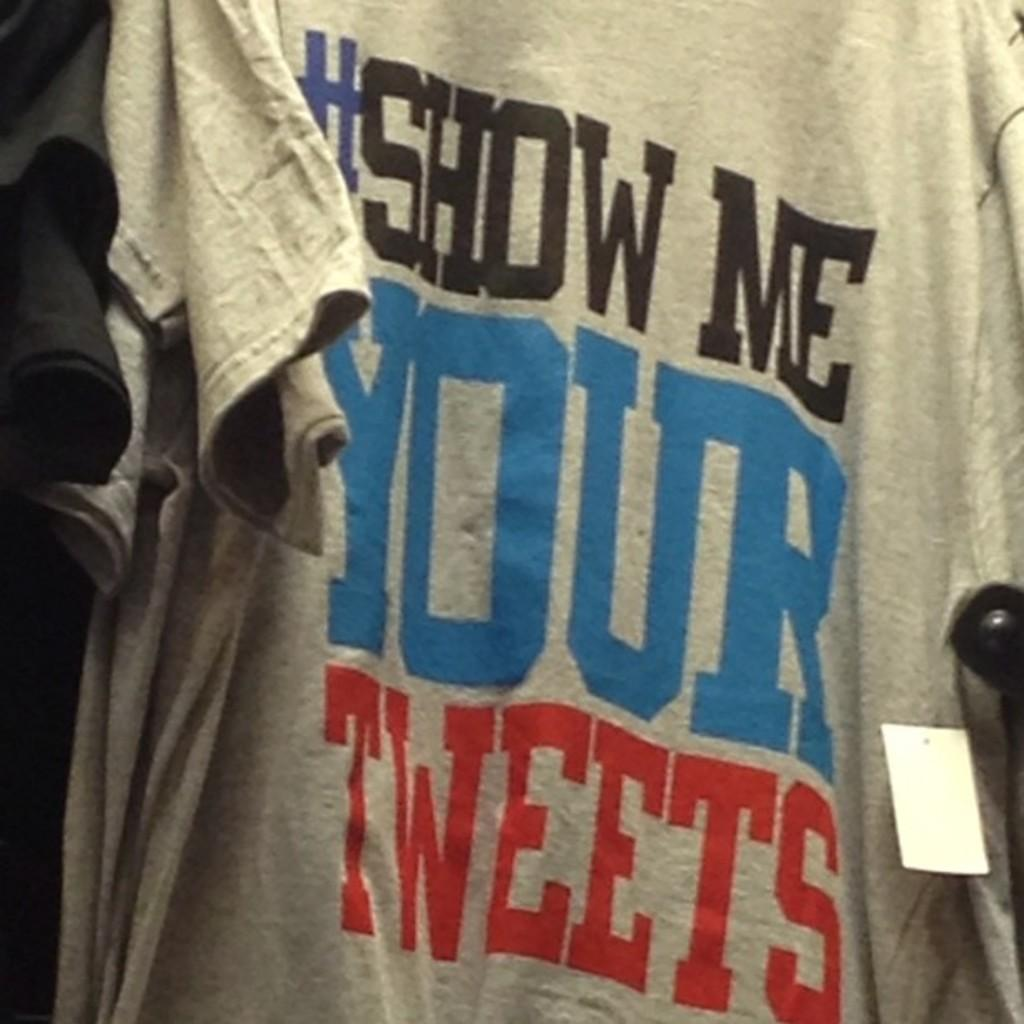<image>
Write a terse but informative summary of the picture. gray tshirt that has #show me your tweets in large letters 